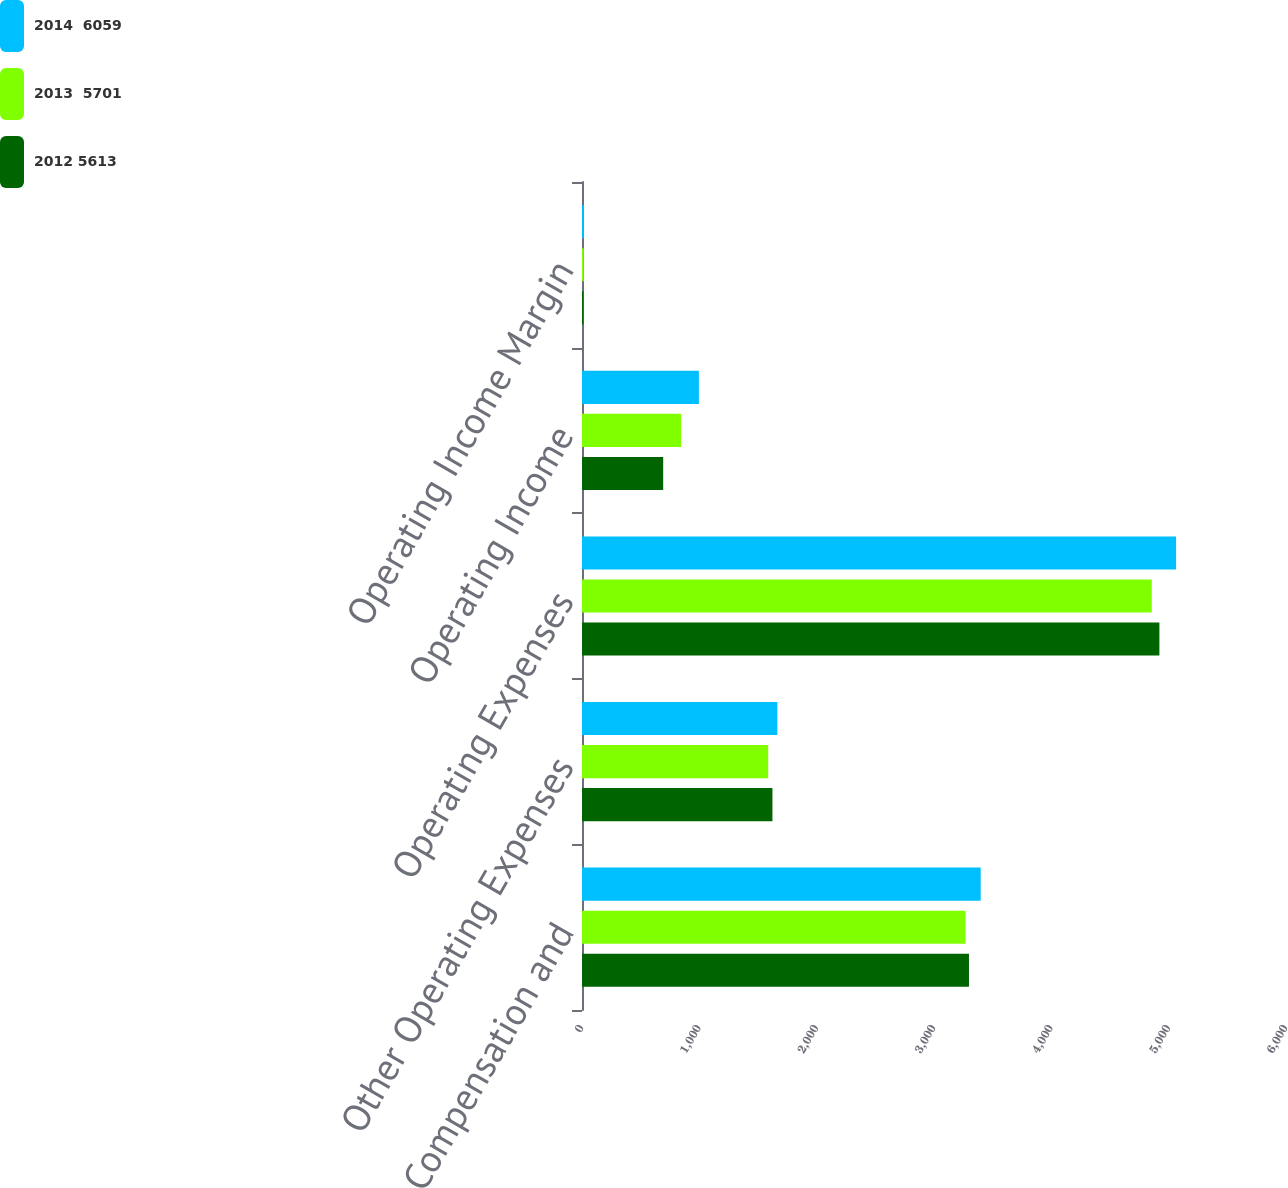Convert chart to OTSL. <chart><loc_0><loc_0><loc_500><loc_500><stacked_bar_chart><ecel><fcel>Revenue Compensation and<fcel>Other Operating Expenses<fcel>Operating Expenses<fcel>Operating Income<fcel>Operating Income Margin<nl><fcel>2014  6059<fcel>3398<fcel>1665<fcel>5063<fcel>996<fcel>16.4<nl><fcel>2013  5701<fcel>3269<fcel>1587<fcel>4856<fcel>845<fcel>14.8<nl><fcel>2012 5613<fcel>3298<fcel>1623<fcel>4921<fcel>692<fcel>12.3<nl></chart> 